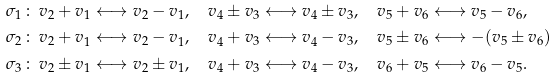Convert formula to latex. <formula><loc_0><loc_0><loc_500><loc_500>\sigma _ { 1 } \, & \colon \, v _ { 2 } + v _ { 1 } \longleftrightarrow v _ { 2 } - v _ { 1 } , \quad v _ { 4 } \pm v _ { 3 } \longleftrightarrow v _ { 4 } \pm v _ { 3 } , \quad v _ { 5 } + v _ { 6 } \longleftrightarrow v _ { 5 } - v _ { 6 } , \\ \sigma _ { 2 } \, & \colon \, v _ { 2 } + v _ { 1 } \longleftrightarrow v _ { 2 } - v _ { 1 } , \quad v _ { 4 } + v _ { 3 } \longleftrightarrow v _ { 4 } - v _ { 3 } , \quad v _ { 5 } \pm v _ { 6 } \longleftrightarrow - ( v _ { 5 } \pm v _ { 6 } ) \\ \sigma _ { 3 } \, & \colon \, v _ { 2 } \pm v _ { 1 } \longleftrightarrow v _ { 2 } \pm v _ { 1 } , \quad v _ { 4 } + v _ { 3 } \longleftrightarrow v _ { 4 } - v _ { 3 } , \quad v _ { 6 } + v _ { 5 } \longleftrightarrow v _ { 6 } - v _ { 5 } .</formula> 